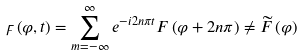Convert formula to latex. <formula><loc_0><loc_0><loc_500><loc_500>\digamma \left ( \varphi , t \right ) = \sum _ { m = - \infty } ^ { \infty } e ^ { - i 2 n \pi t } F \left ( \varphi + 2 n \pi \right ) \neq \widetilde { F } \left ( \varphi \right )</formula> 